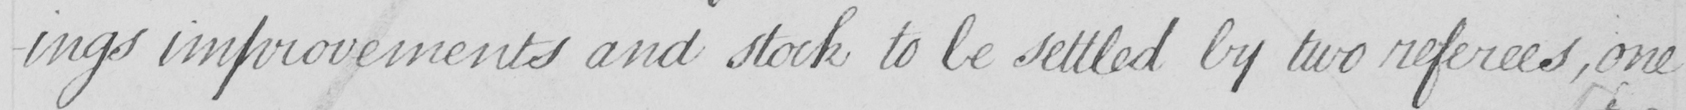What is written in this line of handwriting? -ings improvements and stock to be settled by two referees, one 